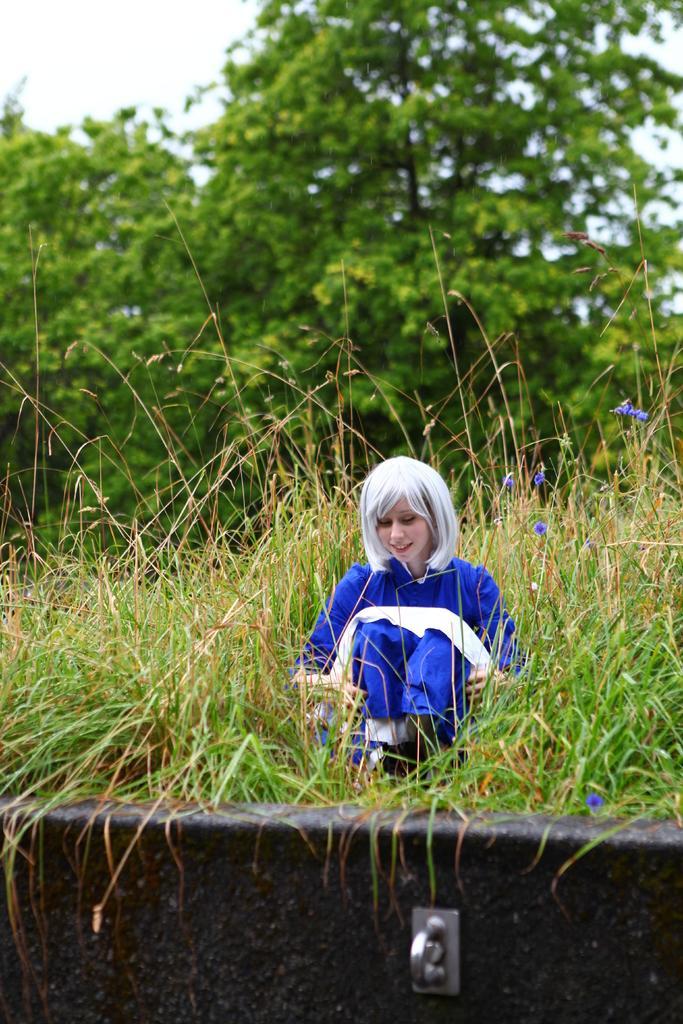Could you give a brief overview of what you see in this image? In this image there is a woman in a blue color dress sitting on the grass,and in the background there are plants with blue color flowers, trees,sky. 